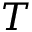<formula> <loc_0><loc_0><loc_500><loc_500>T</formula> 